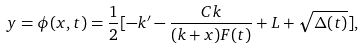<formula> <loc_0><loc_0><loc_500><loc_500>y = \phi ( x , t ) = \frac { 1 } { 2 } [ - k ^ { \prime } - \frac { C k } { ( k + x ) F ( t ) } + L + \sqrt { \Delta ( t ) } ] ,</formula> 